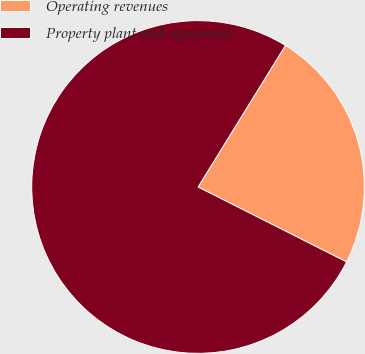Convert chart to OTSL. <chart><loc_0><loc_0><loc_500><loc_500><pie_chart><fcel>Operating revenues<fcel>Property plant and equipment<nl><fcel>23.64%<fcel>76.36%<nl></chart> 